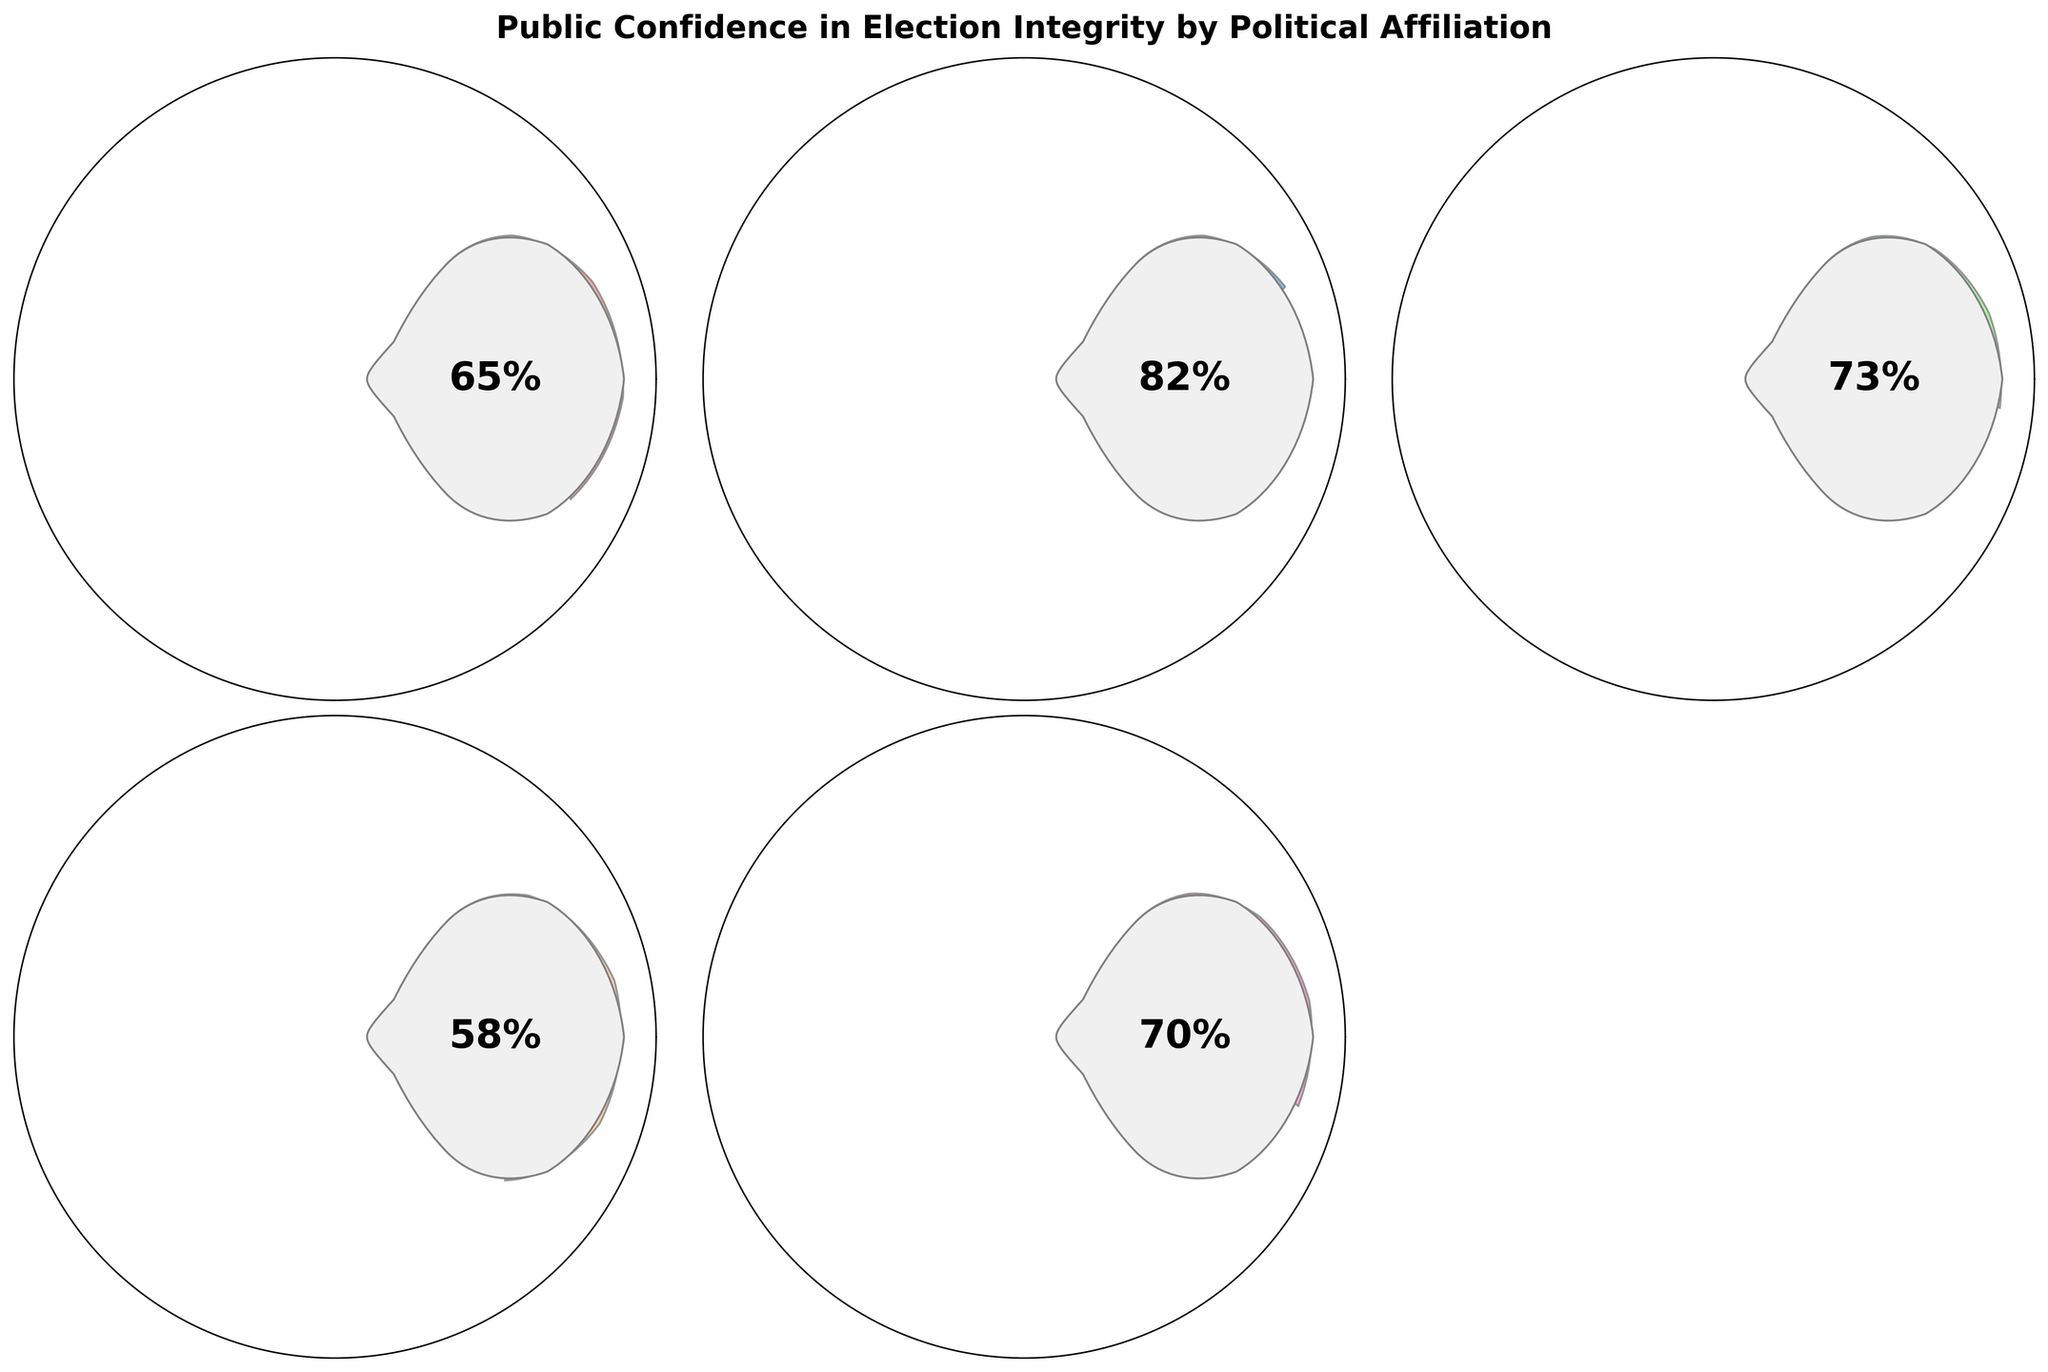Which party has the highest confidence level in election integrity? The party with the most confidence in the figure is the one where the gauge has the smallest empty arc. By examining the figure, that party is the Democrats.
Answer: Democrats Which party has the lowest confidence level in election integrity? By checking the gauges, the confidence level with the largest empty arc belongs to the Libertarians.
Answer: Libertarians What is the range of confidence levels shown across all parties? To find the range, subtract the smallest confidence level from the largest. The highest is 82% (Democrat) and the lowest is 58% (Libertarian), so the range is 82 - 58.
Answer: 24% What is the average confidence level across all parties? Sum the confidence levels: 65 (Republican) + 82 (Democrat) + 73 (Independent) + 58 (Libertarian) + 70 (Green) = 348. Divide by the number of parties (5) to find the average: 348 / 5 = 69.6.
Answer: 69.6% What's the median confidence level among these parties? Arrange the confidence levels in ascending order: 58 (Libertarian), 65 (Republican), 70 (Green), 73 (Independent), 82 (Democrat). The median is the middle value, which is 70.
Answer: 70% What is the difference in confidence levels between Republicans and Libertarians? Subtract the Libertarians' confidence level from the Republicans': 65 - 58 = 7.
Answer: 7 